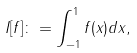Convert formula to latex. <formula><loc_0><loc_0><loc_500><loc_500>I [ f ] \colon = \int _ { - 1 } ^ { 1 } f ( x ) d x ,</formula> 